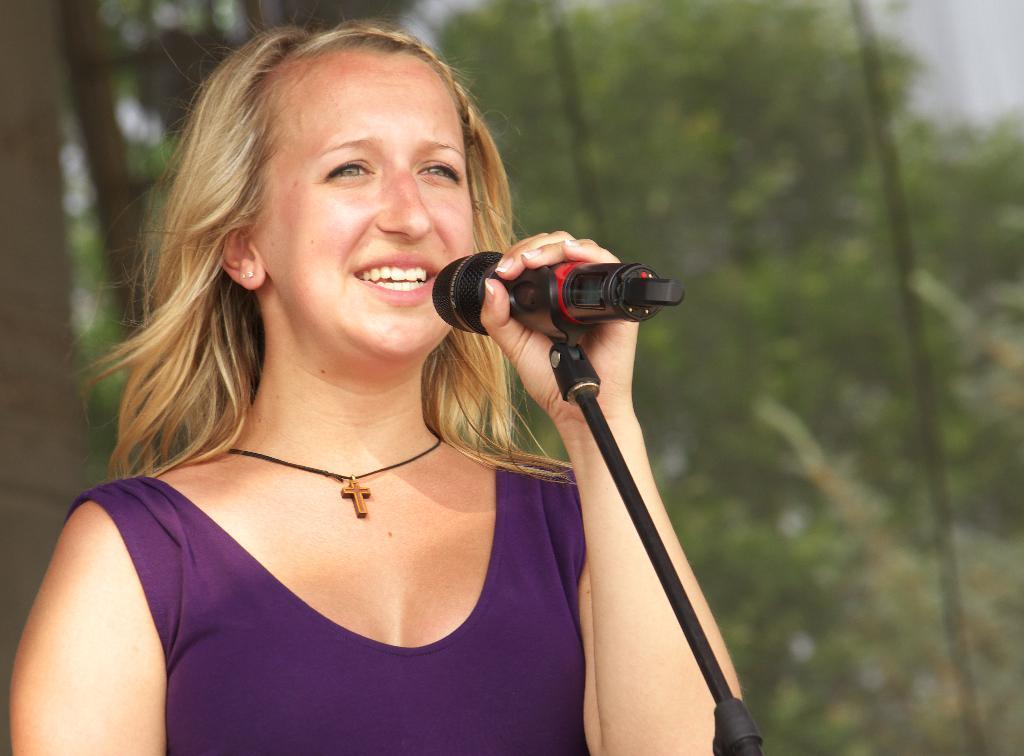Could you give a brief overview of what you see in this image? In this picture there is a woman holding mic might be singing. In the background there are trees. 